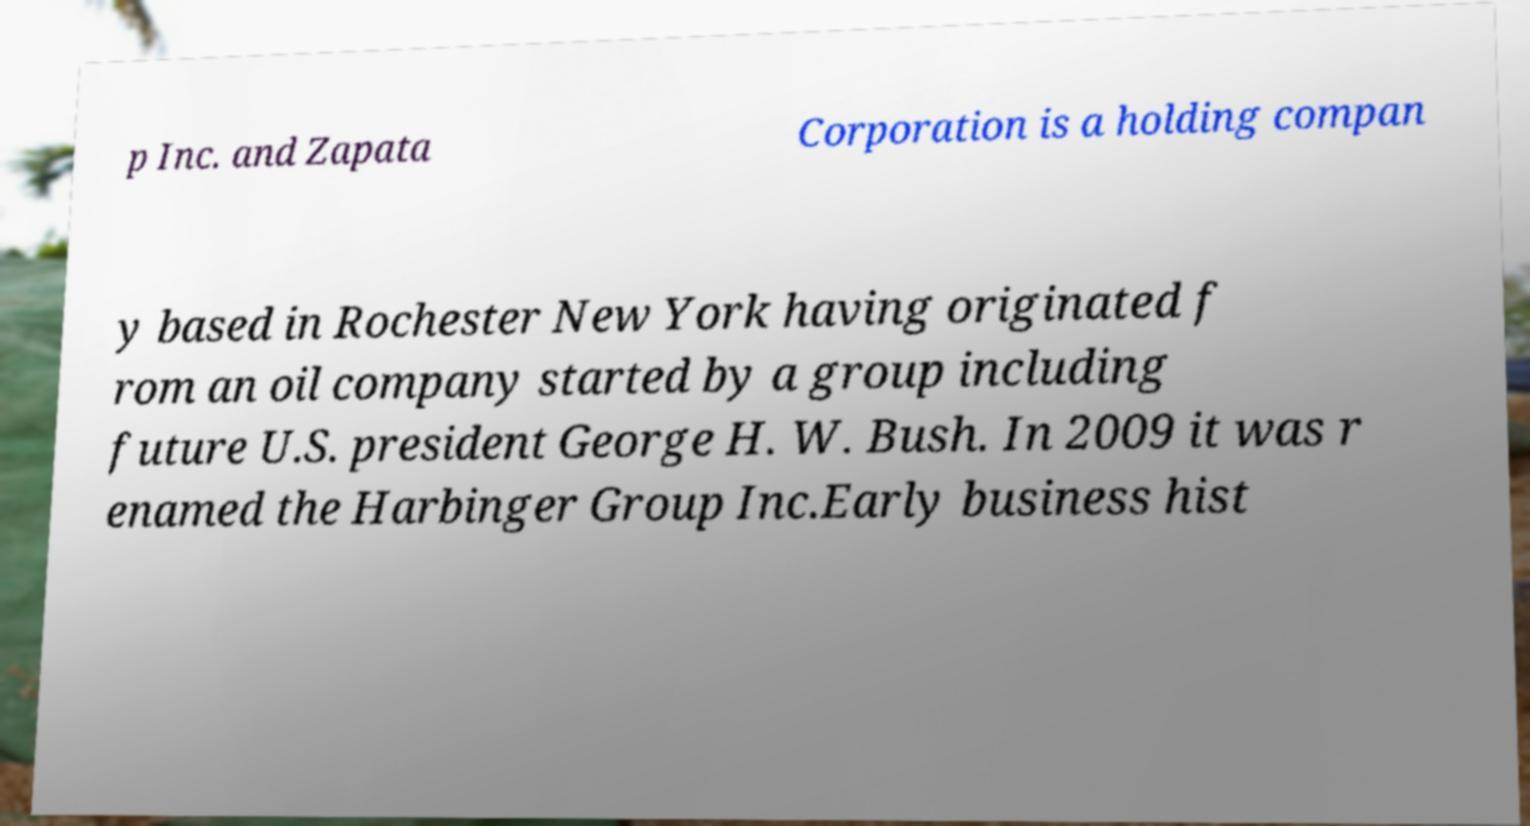Please read and relay the text visible in this image. What does it say? p Inc. and Zapata Corporation is a holding compan y based in Rochester New York having originated f rom an oil company started by a group including future U.S. president George H. W. Bush. In 2009 it was r enamed the Harbinger Group Inc.Early business hist 